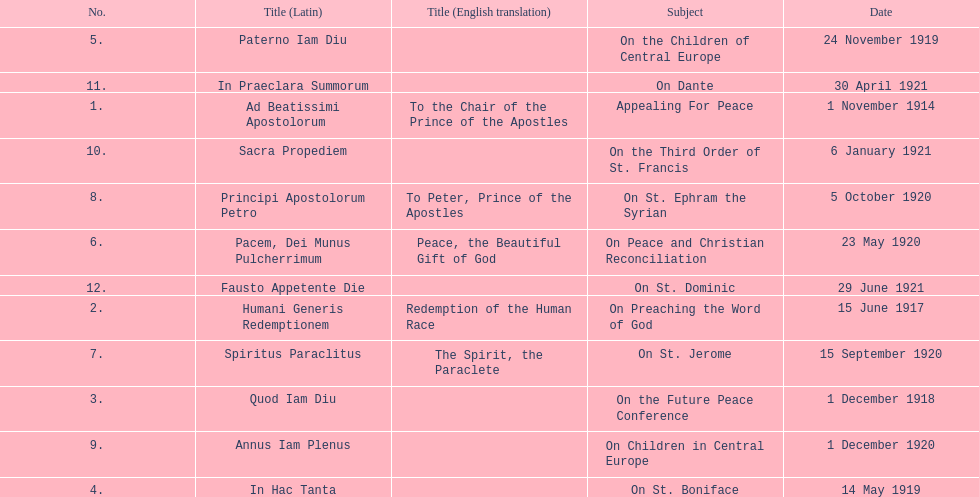How many titles correspond to a date in november? 2. 